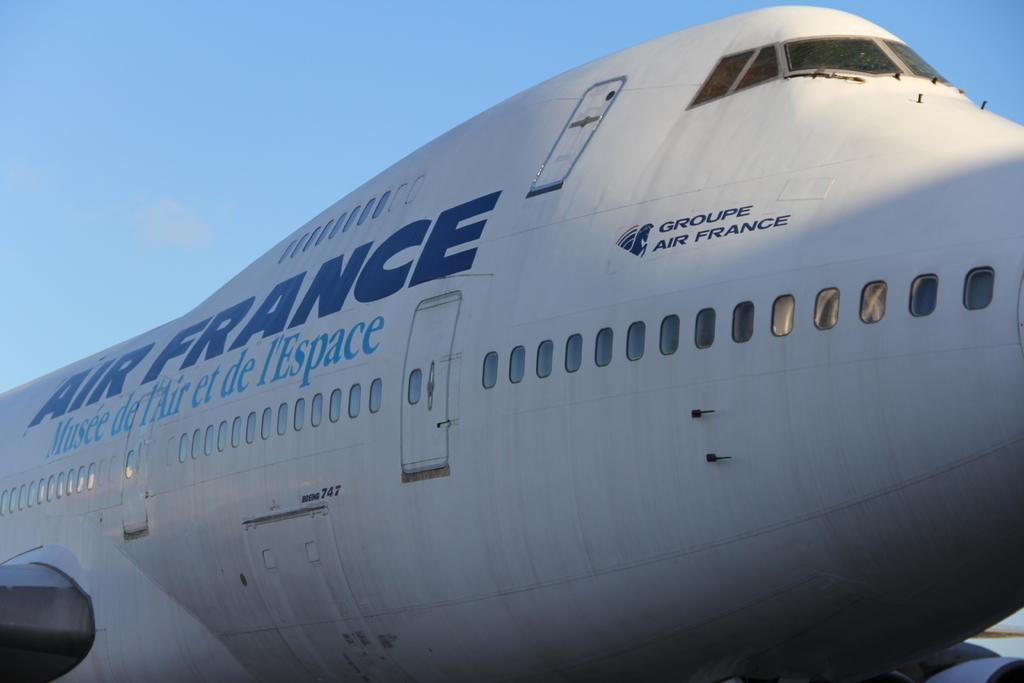What is the main subject of the picture? The main subject of the picture is an airplane. What can be seen in the sky in the image? The sky is visible at the top of the image. Where is the mailbox located in the image? There is no mailbox present in the image. What type of expansion is visible in the image? There is no expansion visible in the image; it features an airplane and the sky. 